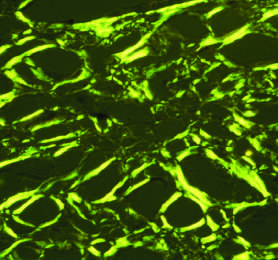what does congo red staining show under polarized light, a diagnostic feature of amyloid?
Answer the question using a single word or phrase. Apple-green birefringence 